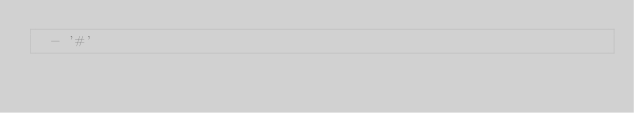<code> <loc_0><loc_0><loc_500><loc_500><_YAML_>  - '#'
</code> 